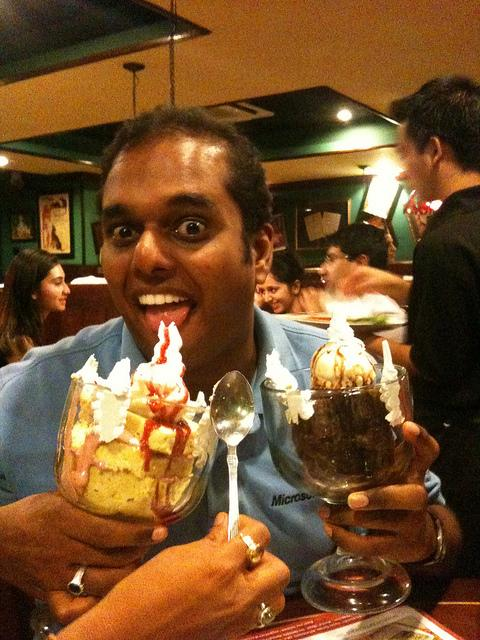What company might the man in the blue shirt work for? microsoft 